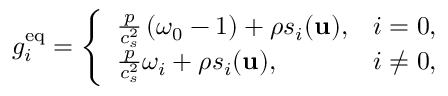Convert formula to latex. <formula><loc_0><loc_0><loc_500><loc_500>g _ { i } ^ { e q } = \left \{ \begin{array} { l l } { \frac { p } { c _ { s } ^ { 2 } } \left ( \omega _ { 0 } - 1 \right ) + \rho s _ { i } ( u ) , } & { i = 0 , } \\ { \frac { p } { c _ { s } ^ { 2 } } \omega _ { i } + \rho s _ { i } ( u ) , } & { i \neq 0 , } \end{array}</formula> 